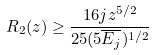Convert formula to latex. <formula><loc_0><loc_0><loc_500><loc_500>R _ { 2 } ( z ) \geq \frac { 1 6 j z ^ { 5 / 2 } } { 2 5 ( 5 \overline { E _ { j } } ) ^ { 1 / 2 } }</formula> 